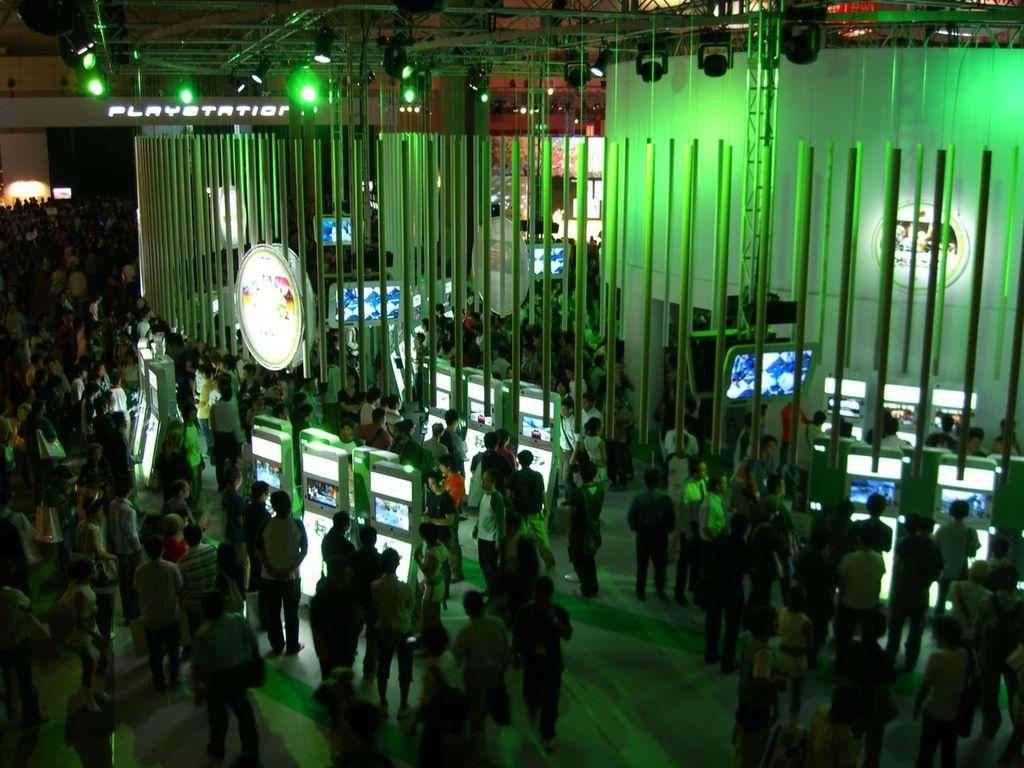How many people are in the group visible in the image? The number of people in the group cannot be determined from the provided facts. What type of electronic devices are present in the image? There are screens in the image. What is the purpose of the banner in the image? The purpose of the banner in the image cannot be determined from the provided facts. What type of illumination is present in the image? There are lights in the image. What type of structure is visible in the image? There is a wall in the image. Can you see any ocean waves in the image? There is no reference to an ocean or waves in the image. What type of glue is being used by the people in the image? There is no indication in the image that any glue is being used. What type of rat is visible in the image? There is no rat present in the image. 